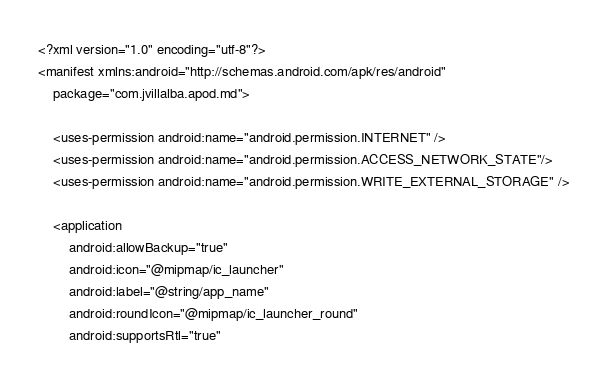<code> <loc_0><loc_0><loc_500><loc_500><_XML_><?xml version="1.0" encoding="utf-8"?>
<manifest xmlns:android="http://schemas.android.com/apk/res/android"
    package="com.jvillalba.apod.md">

    <uses-permission android:name="android.permission.INTERNET" />
    <uses-permission android:name="android.permission.ACCESS_NETWORK_STATE"/>
    <uses-permission android:name="android.permission.WRITE_EXTERNAL_STORAGE" />

    <application
        android:allowBackup="true"
        android:icon="@mipmap/ic_launcher"
        android:label="@string/app_name"
        android:roundIcon="@mipmap/ic_launcher_round"
        android:supportsRtl="true"</code> 